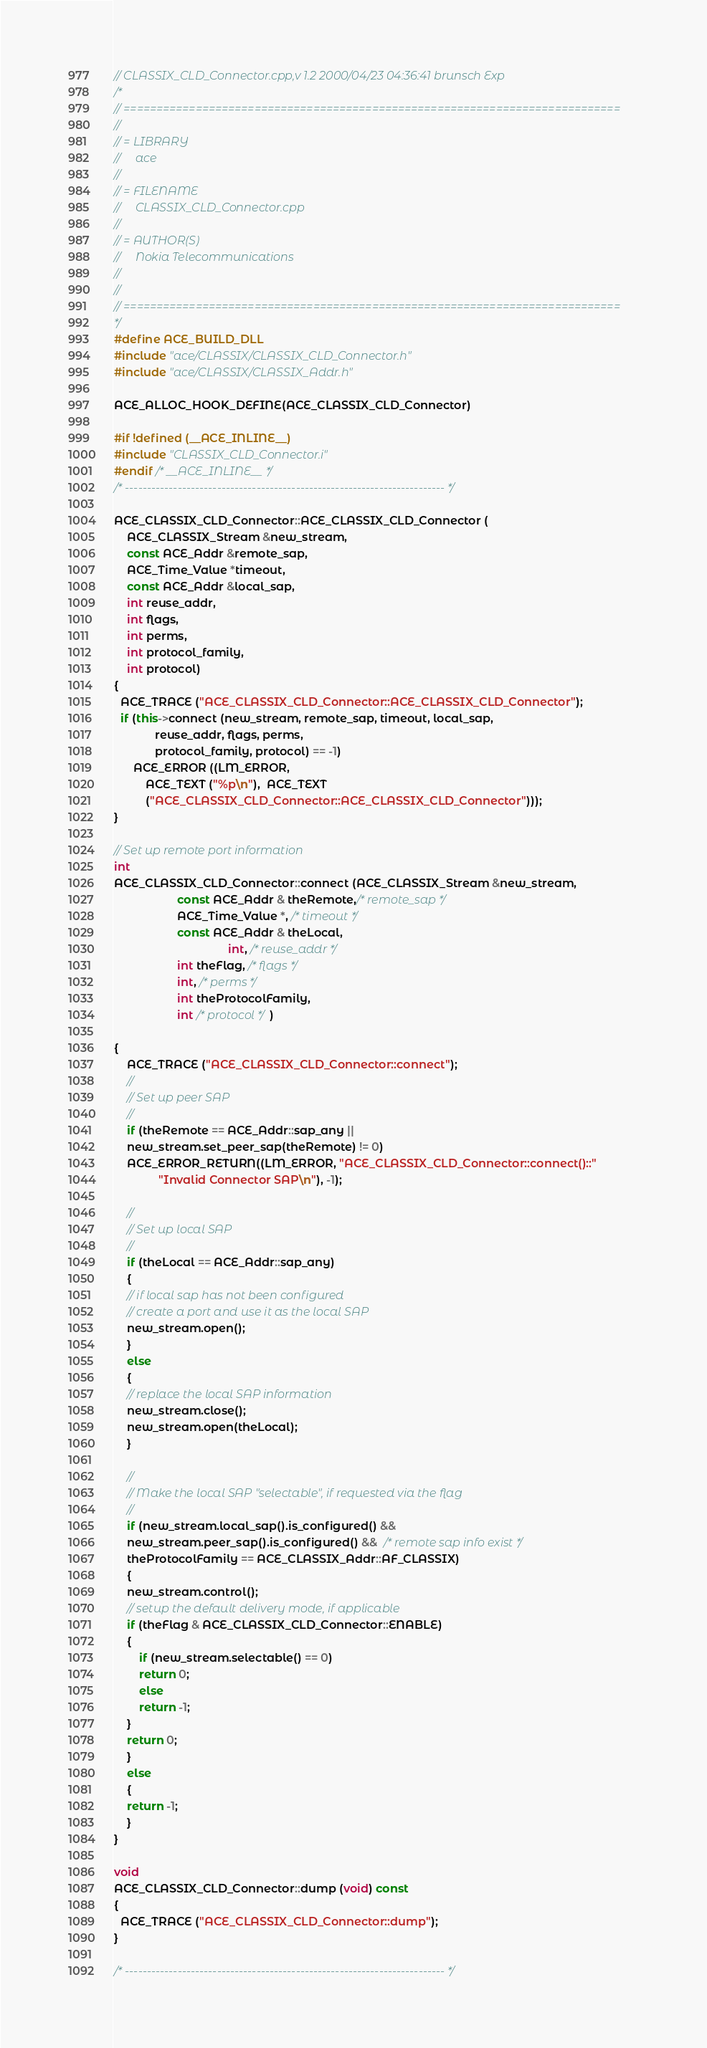Convert code to text. <code><loc_0><loc_0><loc_500><loc_500><_C++_>// CLASSIX_CLD_Connector.cpp,v 1.2 2000/04/23 04:36:41 brunsch Exp
/*
// ============================================================================
//
// = LIBRARY
//     ace
// 
// = FILENAME
//     CLASSIX_CLD_Connector.cpp
//
// = AUTHOR(S)
//     Nokia Telecommunications
// 
//
// ============================================================================
*/
#define ACE_BUILD_DLL
#include "ace/CLASSIX/CLASSIX_CLD_Connector.h"
#include "ace/CLASSIX/CLASSIX_Addr.h"

ACE_ALLOC_HOOK_DEFINE(ACE_CLASSIX_CLD_Connector)

#if !defined (__ACE_INLINE__)
#include "CLASSIX_CLD_Connector.i"
#endif /* __ACE_INLINE__ */
/* ------------------------------------------------------------------------- */

ACE_CLASSIX_CLD_Connector::ACE_CLASSIX_CLD_Connector (
    ACE_CLASSIX_Stream &new_stream, 
    const ACE_Addr &remote_sap, 
    ACE_Time_Value *timeout,
    const ACE_Addr &local_sap,
    int reuse_addr,
    int flags,
    int perms,
    int protocol_family,
    int protocol)
{
  ACE_TRACE ("ACE_CLASSIX_CLD_Connector::ACE_CLASSIX_CLD_Connector");
  if (this->connect (new_stream, remote_sap, timeout, local_sap,
		     reuse_addr, flags, perms, 
		     protocol_family, protocol) == -1)
      ACE_ERROR ((LM_ERROR, 
		  ACE_TEXT ("%p\n"),  ACE_TEXT 
		  ("ACE_CLASSIX_CLD_Connector::ACE_CLASSIX_CLD_Connector")));
}

// Set up remote port information
int
ACE_CLASSIX_CLD_Connector::connect (ACE_CLASSIX_Stream &new_stream, 
				    const ACE_Addr & theRemote,/* remote_sap */
				    ACE_Time_Value *, /* timeout */
				    const ACE_Addr & theLocal,
                                    int, /* reuse_addr */
				    int theFlag, /* flags */
				    int, /* perms */
				    int theProtocolFamily, 
				    int /* protocol */)

{
    ACE_TRACE ("ACE_CLASSIX_CLD_Connector::connect");
    //
    // Set up peer SAP
    // 
    if (theRemote == ACE_Addr::sap_any ||
	new_stream.set_peer_sap(theRemote) != 0)
	ACE_ERROR_RETURN((LM_ERROR, "ACE_CLASSIX_CLD_Connector::connect()::"
			  "Invalid Connector SAP\n"), -1);

    //
    // Set up local SAP
    // 
    if (theLocal == ACE_Addr::sap_any)
    {
	// if local sap has not been configured
	// create a port and use it as the local SAP 
	new_stream.open();
    }
    else
    {
	// replace the local SAP information
	new_stream.close();
	new_stream.open(theLocal);
    }
    
    //
    // Make the local SAP "selectable", if requested via the flag
    // 
    if (new_stream.local_sap().is_configured() && 
	new_stream.peer_sap().is_configured() &&  /* remote sap info exist */
	theProtocolFamily == ACE_CLASSIX_Addr::AF_CLASSIX)
    {
	new_stream.control();
	// setup the default delivery mode, if applicable
	if (theFlag & ACE_CLASSIX_CLD_Connector::ENABLE)
	{
	    if (new_stream.selectable() == 0)
		return 0;
	    else
		return -1;
	}
	return 0;
    }
    else
    {
	return -1;
    }
}

void
ACE_CLASSIX_CLD_Connector::dump (void) const
{
  ACE_TRACE ("ACE_CLASSIX_CLD_Connector::dump");
}

/* ------------------------------------------------------------------------- */
</code> 